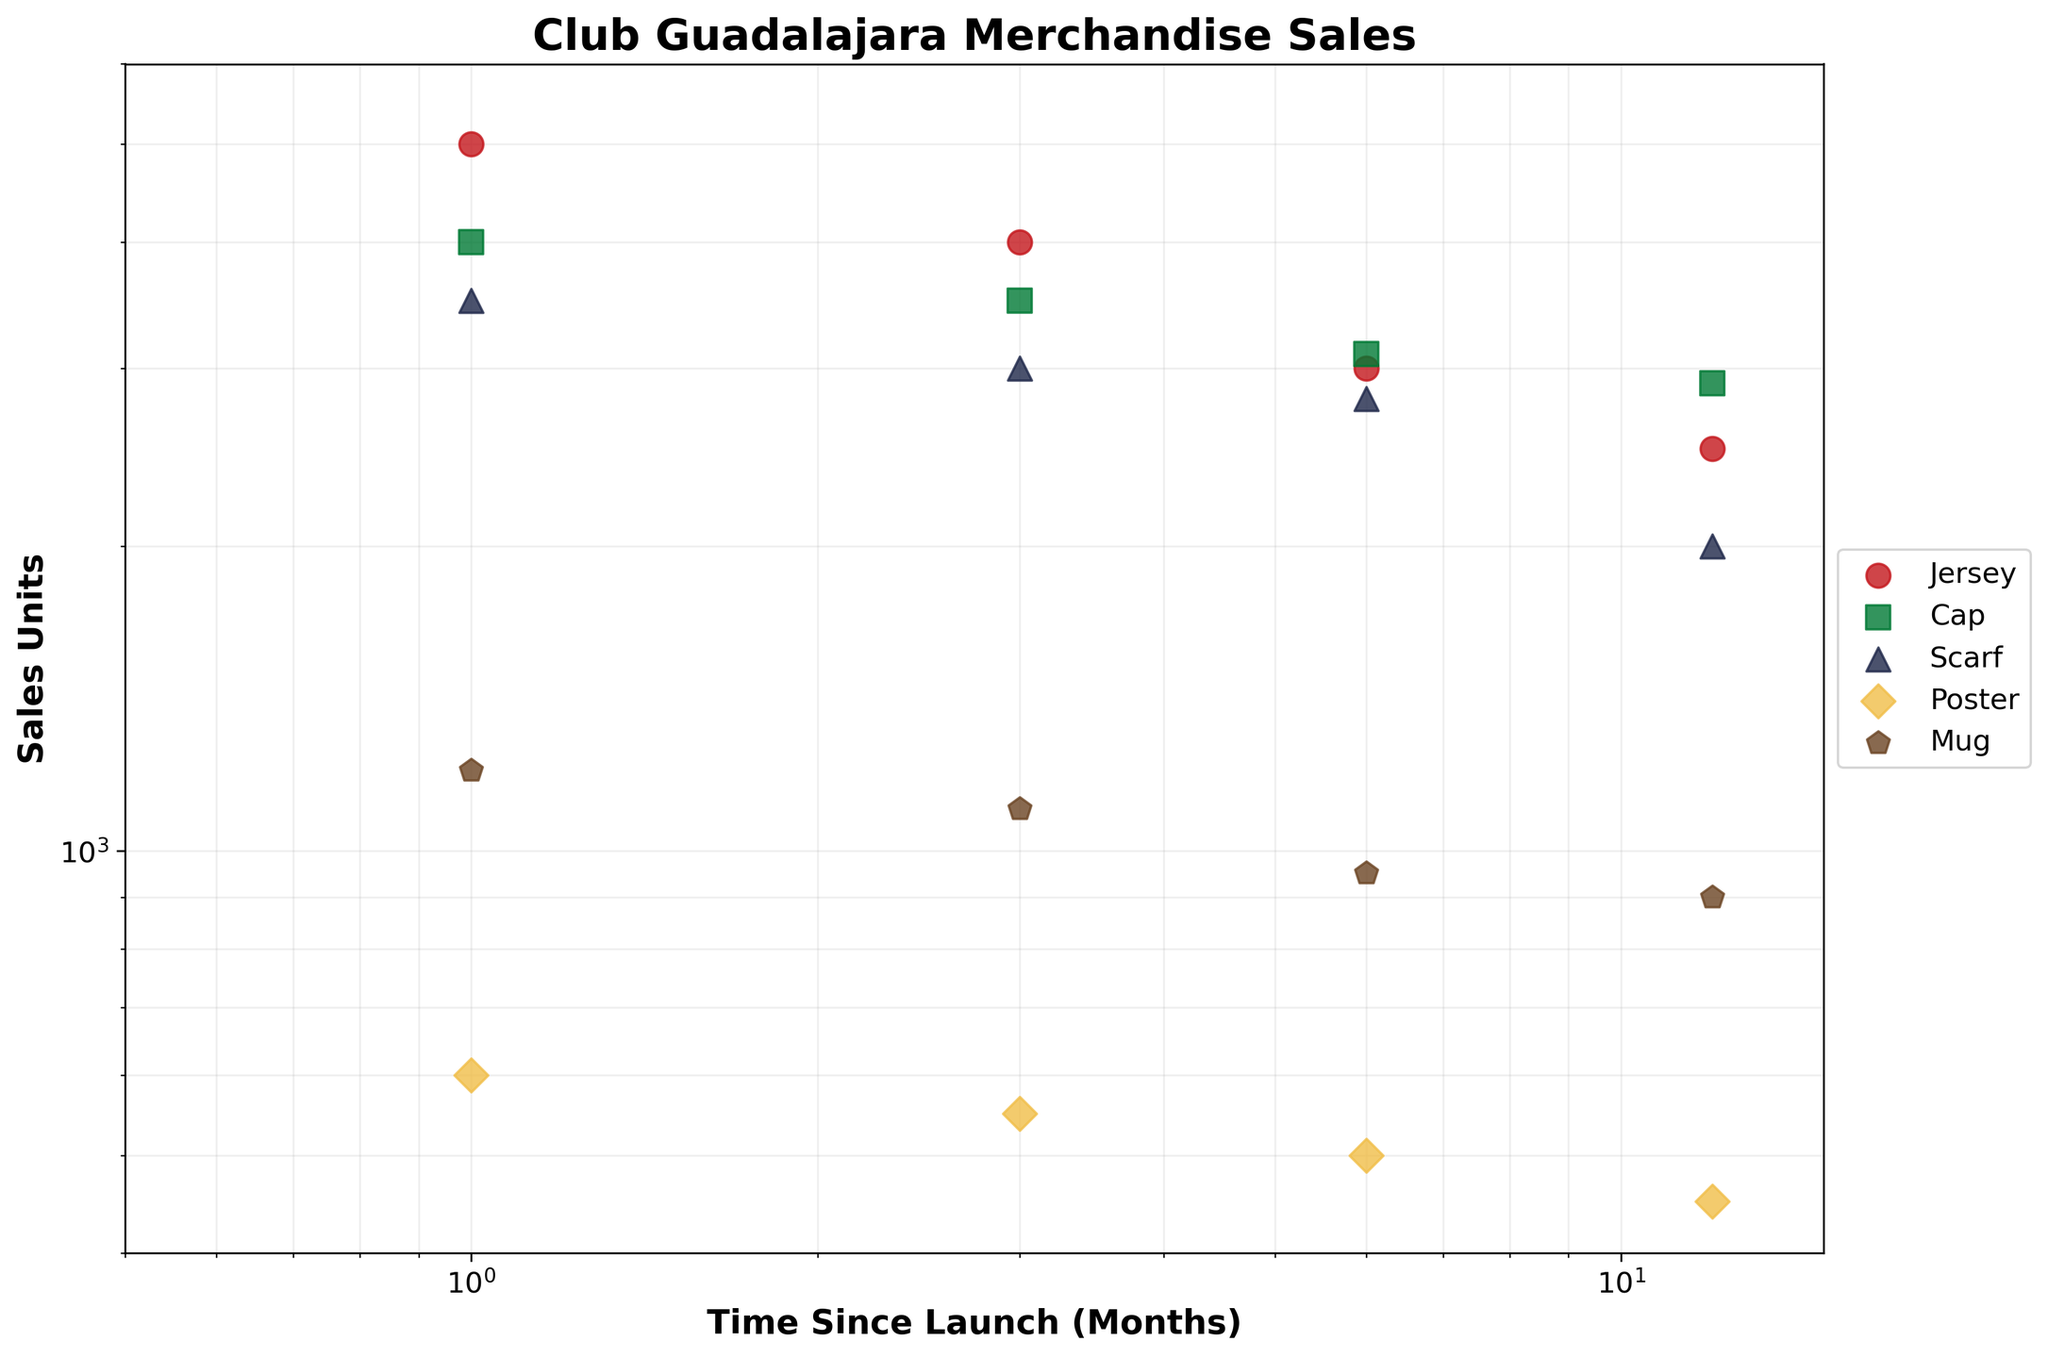What is the title of the scatter plot? The title is usually located at the top of the figure and is written in bold. It describes the main content of the plot.
Answer: Club Guadalajara Merchandise Sales How many product types are represented in the scatter plot? The product types are identified by different markers and colors in the legend adjacent to the plot.
Answer: 5 Which product type had the highest sales units at 1 month since launch? Locate the x-coordinate at 1 month and find the highest y-coordinate. The corresponding marker and color will indicate the product type.
Answer: Jersey How do sales of posters compare to mugs at 6 months since launch? Locate 6 months on the x-axis and compare the y-coordinates for the poster and mug markers. Posters have a sales unit of 500, and mugs have 950.
Answer: Mugs had higher sales than posters What is the range of sales units depicted on the y-axis? The y-axis range can be identified from the axis limits. The range starts from the minimum value to the maximum value shown on the y-axis.
Answer: 400 to 6000 How do jersey sales change over time? Observe the trend of the markers representing jerseys. The y-coordinates (sales units) decrease as the x-coordinates (time) increase.
Answer: Jersey sales decrease over time Which product type shows the least fluctuation in sales over time? Compare the variability in y-coordinates for each product type's markers. Least fluctuation indicates the smallest changes in sales units across different time points.
Answer: Mug What are the sales units for caps at 12 months since launch? Locate 12 months on the x-axis and trace the y-coordinate of the cap marker. The corresponding y-value indicates the sales units.
Answer: 2900 What is the logarithmic scale's benefit for this scatter plot? The logarithmic scale helps to visualize data spread across a wide range, compressing the scale to better distinguish small changes for high-value data points and large changes for low-value data points. This enhances clarity in comparing time series sales data of different magnitudes.
Answer: Better visualization of wide-range data At which time point do scarves and caps exhibit similar sales units, and what are those sales units? Identify time points where markers for scarves and caps are close in y-coordinates. At 6 months, both sales units are closest: scarves at 2800 and caps at 3100.
Answer: 6 months; 2800 and 3100 